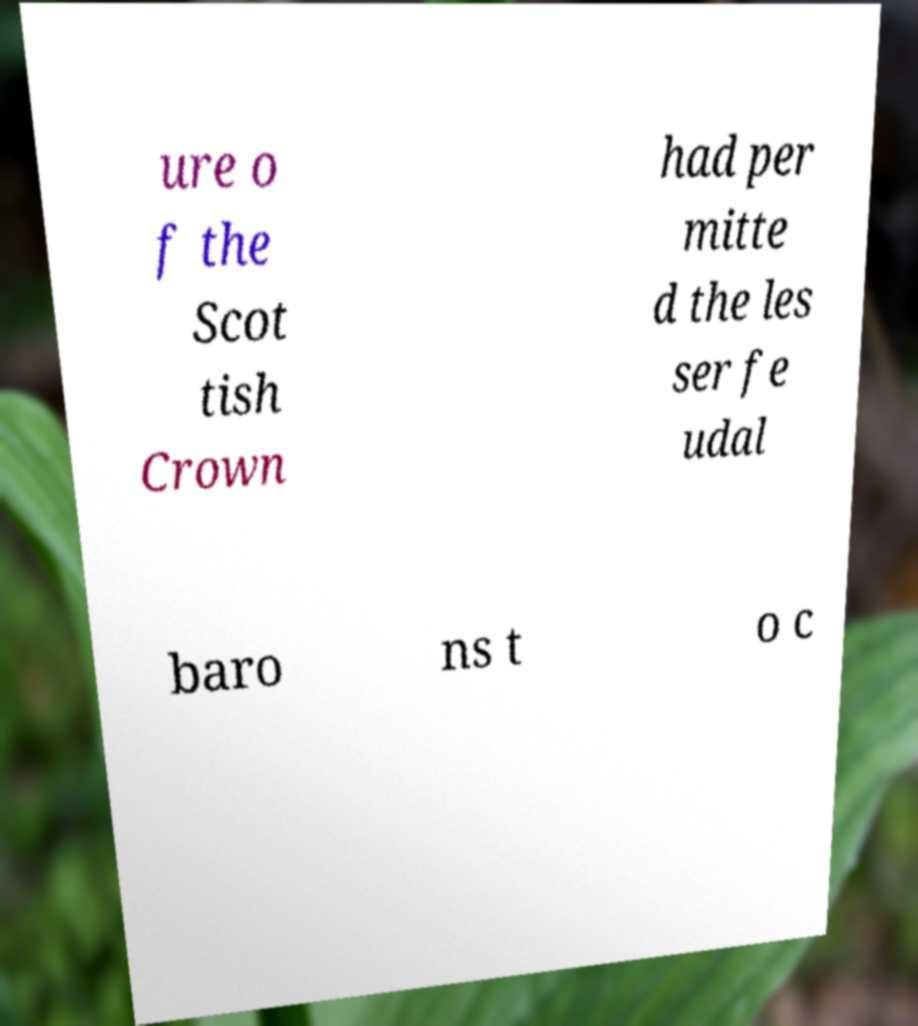For documentation purposes, I need the text within this image transcribed. Could you provide that? ure o f the Scot tish Crown had per mitte d the les ser fe udal baro ns t o c 